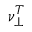Convert formula to latex. <formula><loc_0><loc_0><loc_500><loc_500>\nu _ { \perp } ^ { T }</formula> 